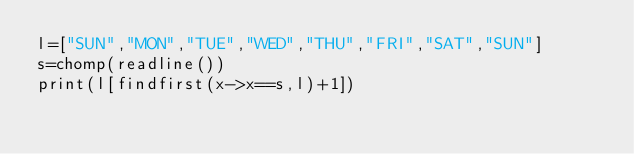<code> <loc_0><loc_0><loc_500><loc_500><_Julia_>l=["SUN","MON","TUE","WED","THU","FRI","SAT","SUN"]
s=chomp(readline())
print(l[findfirst(x->x==s,l)+1])</code> 